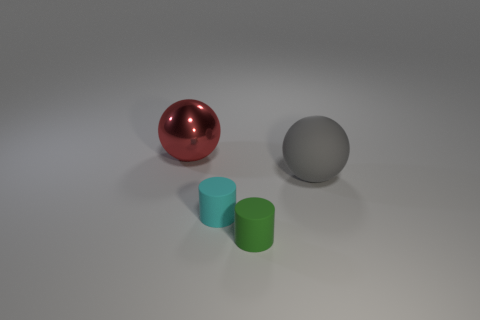How do the objects in the image interact with the lighting? The lighting in the image creates a soft shadow on the ground for each object, indicating a light source coming from above, slightly to the right. The red sphere has a bright highlight on its top right, signifying its reflective and smooth surface. The gray sphere and the cylinders reflect much less light, showing their less reflective, more diffuse surfaces. 